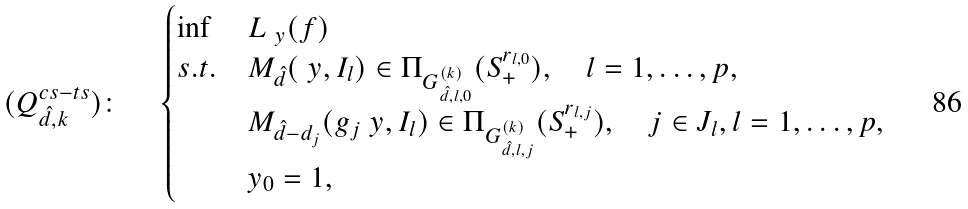<formula> <loc_0><loc_0><loc_500><loc_500>( Q ^ { c s - t s } _ { \hat { d } , k } ) \colon \quad \begin{cases} \inf & L _ { \ y } ( f ) \\ s . t . & M _ { \hat { d } } ( \ y , I _ { l } ) \in \Pi _ { G _ { \hat { d } , l , 0 } ^ { ( k ) } } ( S _ { + } ^ { r _ { l , 0 } } ) , \quad l = 1 , \dots , p , \\ & M _ { \hat { d } - d _ { j } } ( g _ { j } \ y , I _ { l } ) \in \Pi _ { G _ { \hat { d } , l , j } ^ { ( k ) } } ( S _ { + } ^ { r _ { l , j } } ) , \quad j \in J _ { l } , l = 1 , \dots , p , \\ & y _ { 0 } = 1 , \end{cases}</formula> 